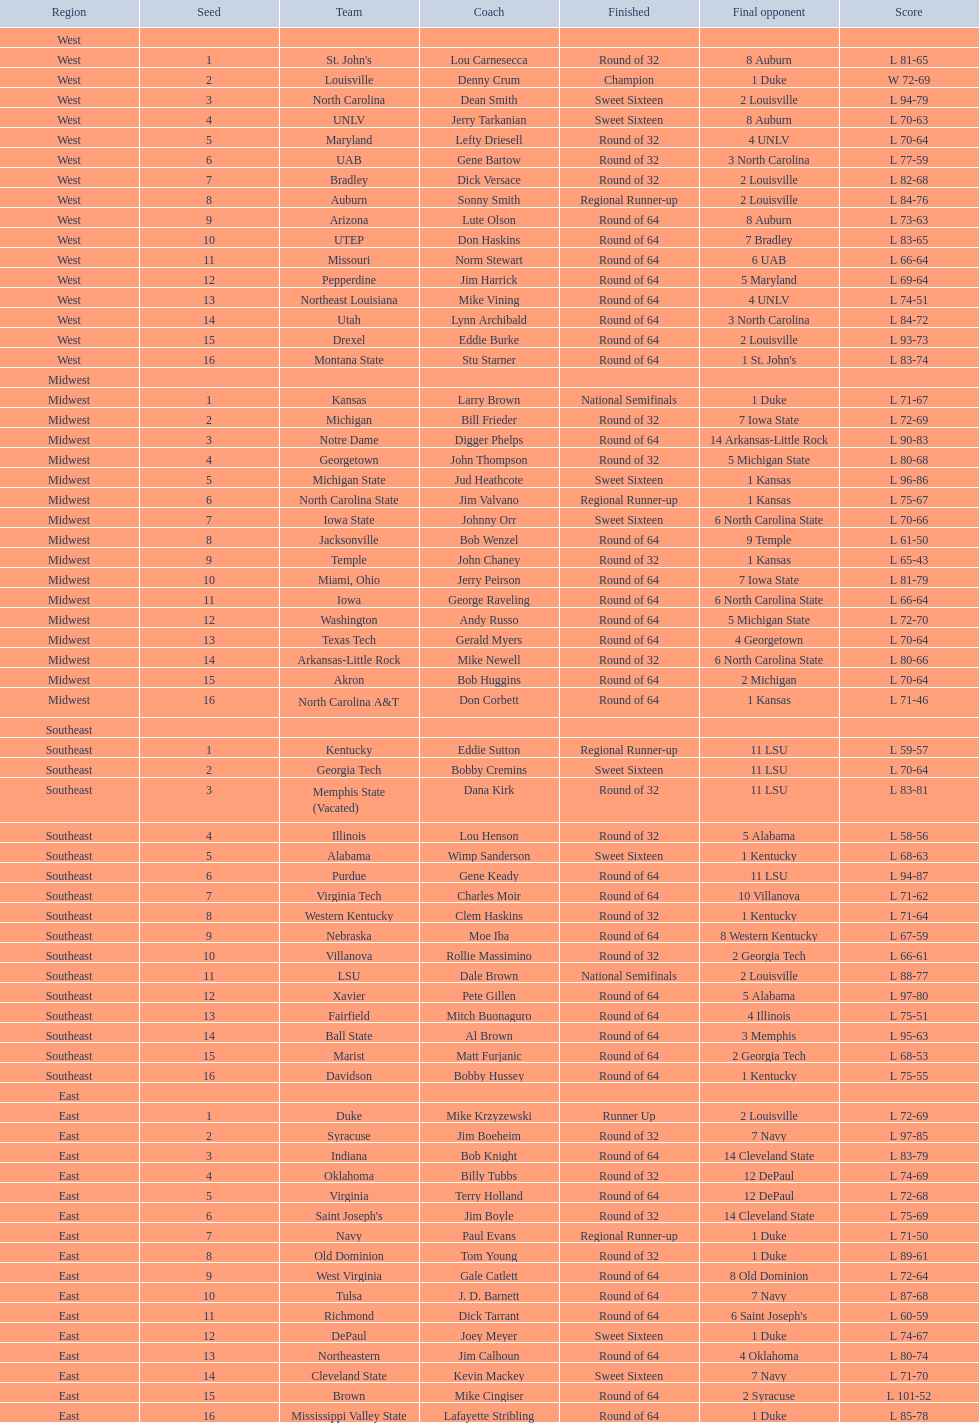Can you parse all the data within this table? {'header': ['Region', 'Seed', 'Team', 'Coach', 'Finished', 'Final opponent', 'Score'], 'rows': [['West', '', '', '', '', '', ''], ['West', '1', "St. John's", 'Lou Carnesecca', 'Round of 32', '8 Auburn', 'L 81-65'], ['West', '2', 'Louisville', 'Denny Crum', 'Champion', '1 Duke', 'W 72-69'], ['West', '3', 'North Carolina', 'Dean Smith', 'Sweet Sixteen', '2 Louisville', 'L 94-79'], ['West', '4', 'UNLV', 'Jerry Tarkanian', 'Sweet Sixteen', '8 Auburn', 'L 70-63'], ['West', '5', 'Maryland', 'Lefty Driesell', 'Round of 32', '4 UNLV', 'L 70-64'], ['West', '6', 'UAB', 'Gene Bartow', 'Round of 32', '3 North Carolina', 'L 77-59'], ['West', '7', 'Bradley', 'Dick Versace', 'Round of 32', '2 Louisville', 'L 82-68'], ['West', '8', 'Auburn', 'Sonny Smith', 'Regional Runner-up', '2 Louisville', 'L 84-76'], ['West', '9', 'Arizona', 'Lute Olson', 'Round of 64', '8 Auburn', 'L 73-63'], ['West', '10', 'UTEP', 'Don Haskins', 'Round of 64', '7 Bradley', 'L 83-65'], ['West', '11', 'Missouri', 'Norm Stewart', 'Round of 64', '6 UAB', 'L 66-64'], ['West', '12', 'Pepperdine', 'Jim Harrick', 'Round of 64', '5 Maryland', 'L 69-64'], ['West', '13', 'Northeast Louisiana', 'Mike Vining', 'Round of 64', '4 UNLV', 'L 74-51'], ['West', '14', 'Utah', 'Lynn Archibald', 'Round of 64', '3 North Carolina', 'L 84-72'], ['West', '15', 'Drexel', 'Eddie Burke', 'Round of 64', '2 Louisville', 'L 93-73'], ['West', '16', 'Montana State', 'Stu Starner', 'Round of 64', "1 St. John's", 'L 83-74'], ['Midwest', '', '', '', '', '', ''], ['Midwest', '1', 'Kansas', 'Larry Brown', 'National Semifinals', '1 Duke', 'L 71-67'], ['Midwest', '2', 'Michigan', 'Bill Frieder', 'Round of 32', '7 Iowa State', 'L 72-69'], ['Midwest', '3', 'Notre Dame', 'Digger Phelps', 'Round of 64', '14 Arkansas-Little Rock', 'L 90-83'], ['Midwest', '4', 'Georgetown', 'John Thompson', 'Round of 32', '5 Michigan State', 'L 80-68'], ['Midwest', '5', 'Michigan State', 'Jud Heathcote', 'Sweet Sixteen', '1 Kansas', 'L 96-86'], ['Midwest', '6', 'North Carolina State', 'Jim Valvano', 'Regional Runner-up', '1 Kansas', 'L 75-67'], ['Midwest', '7', 'Iowa State', 'Johnny Orr', 'Sweet Sixteen', '6 North Carolina State', 'L 70-66'], ['Midwest', '8', 'Jacksonville', 'Bob Wenzel', 'Round of 64', '9 Temple', 'L 61-50'], ['Midwest', '9', 'Temple', 'John Chaney', 'Round of 32', '1 Kansas', 'L 65-43'], ['Midwest', '10', 'Miami, Ohio', 'Jerry Peirson', 'Round of 64', '7 Iowa State', 'L 81-79'], ['Midwest', '11', 'Iowa', 'George Raveling', 'Round of 64', '6 North Carolina State', 'L 66-64'], ['Midwest', '12', 'Washington', 'Andy Russo', 'Round of 64', '5 Michigan State', 'L 72-70'], ['Midwest', '13', 'Texas Tech', 'Gerald Myers', 'Round of 64', '4 Georgetown', 'L 70-64'], ['Midwest', '14', 'Arkansas-Little Rock', 'Mike Newell', 'Round of 32', '6 North Carolina State', 'L 80-66'], ['Midwest', '15', 'Akron', 'Bob Huggins', 'Round of 64', '2 Michigan', 'L 70-64'], ['Midwest', '16', 'North Carolina A&T', 'Don Corbett', 'Round of 64', '1 Kansas', 'L 71-46'], ['Southeast', '', '', '', '', '', ''], ['Southeast', '1', 'Kentucky', 'Eddie Sutton', 'Regional Runner-up', '11 LSU', 'L 59-57'], ['Southeast', '2', 'Georgia Tech', 'Bobby Cremins', 'Sweet Sixteen', '11 LSU', 'L 70-64'], ['Southeast', '3', 'Memphis State (Vacated)', 'Dana Kirk', 'Round of 32', '11 LSU', 'L 83-81'], ['Southeast', '4', 'Illinois', 'Lou Henson', 'Round of 32', '5 Alabama', 'L 58-56'], ['Southeast', '5', 'Alabama', 'Wimp Sanderson', 'Sweet Sixteen', '1 Kentucky', 'L 68-63'], ['Southeast', '6', 'Purdue', 'Gene Keady', 'Round of 64', '11 LSU', 'L 94-87'], ['Southeast', '7', 'Virginia Tech', 'Charles Moir', 'Round of 64', '10 Villanova', 'L 71-62'], ['Southeast', '8', 'Western Kentucky', 'Clem Haskins', 'Round of 32', '1 Kentucky', 'L 71-64'], ['Southeast', '9', 'Nebraska', 'Moe Iba', 'Round of 64', '8 Western Kentucky', 'L 67-59'], ['Southeast', '10', 'Villanova', 'Rollie Massimino', 'Round of 32', '2 Georgia Tech', 'L 66-61'], ['Southeast', '11', 'LSU', 'Dale Brown', 'National Semifinals', '2 Louisville', 'L 88-77'], ['Southeast', '12', 'Xavier', 'Pete Gillen', 'Round of 64', '5 Alabama', 'L 97-80'], ['Southeast', '13', 'Fairfield', 'Mitch Buonaguro', 'Round of 64', '4 Illinois', 'L 75-51'], ['Southeast', '14', 'Ball State', 'Al Brown', 'Round of 64', '3 Memphis', 'L 95-63'], ['Southeast', '15', 'Marist', 'Matt Furjanic', 'Round of 64', '2 Georgia Tech', 'L 68-53'], ['Southeast', '16', 'Davidson', 'Bobby Hussey', 'Round of 64', '1 Kentucky', 'L 75-55'], ['East', '', '', '', '', '', ''], ['East', '1', 'Duke', 'Mike Krzyzewski', 'Runner Up', '2 Louisville', 'L 72-69'], ['East', '2', 'Syracuse', 'Jim Boeheim', 'Round of 32', '7 Navy', 'L 97-85'], ['East', '3', 'Indiana', 'Bob Knight', 'Round of 64', '14 Cleveland State', 'L 83-79'], ['East', '4', 'Oklahoma', 'Billy Tubbs', 'Round of 32', '12 DePaul', 'L 74-69'], ['East', '5', 'Virginia', 'Terry Holland', 'Round of 64', '12 DePaul', 'L 72-68'], ['East', '6', "Saint Joseph's", 'Jim Boyle', 'Round of 32', '14 Cleveland State', 'L 75-69'], ['East', '7', 'Navy', 'Paul Evans', 'Regional Runner-up', '1 Duke', 'L 71-50'], ['East', '8', 'Old Dominion', 'Tom Young', 'Round of 32', '1 Duke', 'L 89-61'], ['East', '9', 'West Virginia', 'Gale Catlett', 'Round of 64', '8 Old Dominion', 'L 72-64'], ['East', '10', 'Tulsa', 'J. D. Barnett', 'Round of 64', '7 Navy', 'L 87-68'], ['East', '11', 'Richmond', 'Dick Tarrant', 'Round of 64', "6 Saint Joseph's", 'L 60-59'], ['East', '12', 'DePaul', 'Joey Meyer', 'Sweet Sixteen', '1 Duke', 'L 74-67'], ['East', '13', 'Northeastern', 'Jim Calhoun', 'Round of 64', '4 Oklahoma', 'L 80-74'], ['East', '14', 'Cleveland State', 'Kevin Mackey', 'Sweet Sixteen', '7 Navy', 'L 71-70'], ['East', '15', 'Brown', 'Mike Cingiser', 'Round of 64', '2 Syracuse', 'L 101-52'], ['East', '16', 'Mississippi Valley State', 'Lafayette Stribling', 'Round of 64', '1 Duke', 'L 85-78']]} What team finished at the top of all else and was finished as champions? Louisville. 